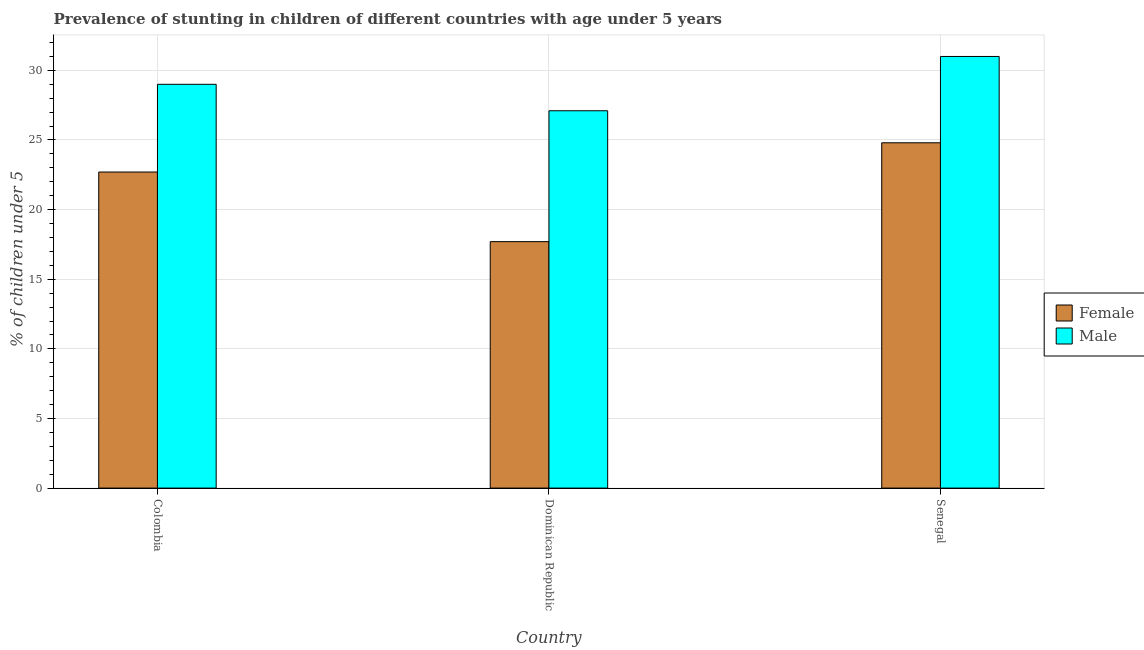How many groups of bars are there?
Keep it short and to the point. 3. Are the number of bars on each tick of the X-axis equal?
Keep it short and to the point. Yes. How many bars are there on the 1st tick from the left?
Offer a very short reply. 2. How many bars are there on the 3rd tick from the right?
Your answer should be compact. 2. What is the percentage of stunted female children in Colombia?
Offer a terse response. 22.7. Across all countries, what is the minimum percentage of stunted male children?
Give a very brief answer. 27.1. In which country was the percentage of stunted female children maximum?
Your answer should be very brief. Senegal. In which country was the percentage of stunted female children minimum?
Your response must be concise. Dominican Republic. What is the total percentage of stunted female children in the graph?
Your answer should be very brief. 65.2. What is the difference between the percentage of stunted female children in Colombia and that in Senegal?
Keep it short and to the point. -2.1. What is the difference between the percentage of stunted female children in Senegal and the percentage of stunted male children in Colombia?
Offer a very short reply. -4.2. What is the average percentage of stunted female children per country?
Provide a short and direct response. 21.73. What is the difference between the percentage of stunted female children and percentage of stunted male children in Colombia?
Offer a terse response. -6.3. What is the ratio of the percentage of stunted male children in Dominican Republic to that in Senegal?
Ensure brevity in your answer.  0.87. Is the difference between the percentage of stunted male children in Dominican Republic and Senegal greater than the difference between the percentage of stunted female children in Dominican Republic and Senegal?
Give a very brief answer. Yes. What is the difference between the highest and the second highest percentage of stunted female children?
Your answer should be very brief. 2.1. What is the difference between the highest and the lowest percentage of stunted male children?
Your answer should be very brief. 3.9. In how many countries, is the percentage of stunted female children greater than the average percentage of stunted female children taken over all countries?
Offer a terse response. 2. Is the sum of the percentage of stunted male children in Colombia and Dominican Republic greater than the maximum percentage of stunted female children across all countries?
Provide a succinct answer. Yes. What does the 1st bar from the left in Dominican Republic represents?
Your answer should be very brief. Female. What does the 2nd bar from the right in Colombia represents?
Your answer should be very brief. Female. How many bars are there?
Your response must be concise. 6. What is the difference between two consecutive major ticks on the Y-axis?
Your answer should be very brief. 5. Does the graph contain any zero values?
Your answer should be very brief. No. How many legend labels are there?
Provide a short and direct response. 2. How are the legend labels stacked?
Keep it short and to the point. Vertical. What is the title of the graph?
Provide a succinct answer. Prevalence of stunting in children of different countries with age under 5 years. What is the label or title of the X-axis?
Provide a succinct answer. Country. What is the label or title of the Y-axis?
Ensure brevity in your answer.   % of children under 5. What is the  % of children under 5 in Female in Colombia?
Offer a terse response. 22.7. What is the  % of children under 5 in Male in Colombia?
Offer a terse response. 29. What is the  % of children under 5 of Female in Dominican Republic?
Provide a succinct answer. 17.7. What is the  % of children under 5 in Male in Dominican Republic?
Offer a terse response. 27.1. What is the  % of children under 5 of Female in Senegal?
Keep it short and to the point. 24.8. What is the  % of children under 5 of Male in Senegal?
Offer a terse response. 31. Across all countries, what is the maximum  % of children under 5 of Female?
Offer a terse response. 24.8. Across all countries, what is the minimum  % of children under 5 in Female?
Provide a short and direct response. 17.7. Across all countries, what is the minimum  % of children under 5 in Male?
Ensure brevity in your answer.  27.1. What is the total  % of children under 5 of Female in the graph?
Offer a terse response. 65.2. What is the total  % of children under 5 of Male in the graph?
Offer a terse response. 87.1. What is the difference between the  % of children under 5 in Female in Colombia and that in Dominican Republic?
Ensure brevity in your answer.  5. What is the difference between the  % of children under 5 in Female in Colombia and that in Senegal?
Your answer should be compact. -2.1. What is the difference between the  % of children under 5 in Female in Dominican Republic and that in Senegal?
Offer a terse response. -7.1. What is the difference between the  % of children under 5 in Female in Colombia and the  % of children under 5 in Male in Senegal?
Keep it short and to the point. -8.3. What is the difference between the  % of children under 5 of Female in Dominican Republic and the  % of children under 5 of Male in Senegal?
Provide a short and direct response. -13.3. What is the average  % of children under 5 of Female per country?
Offer a very short reply. 21.73. What is the average  % of children under 5 of Male per country?
Make the answer very short. 29.03. What is the difference between the  % of children under 5 in Female and  % of children under 5 in Male in Colombia?
Provide a succinct answer. -6.3. What is the difference between the  % of children under 5 of Female and  % of children under 5 of Male in Dominican Republic?
Ensure brevity in your answer.  -9.4. What is the ratio of the  % of children under 5 of Female in Colombia to that in Dominican Republic?
Provide a succinct answer. 1.28. What is the ratio of the  % of children under 5 in Male in Colombia to that in Dominican Republic?
Offer a very short reply. 1.07. What is the ratio of the  % of children under 5 of Female in Colombia to that in Senegal?
Keep it short and to the point. 0.92. What is the ratio of the  % of children under 5 of Male in Colombia to that in Senegal?
Make the answer very short. 0.94. What is the ratio of the  % of children under 5 of Female in Dominican Republic to that in Senegal?
Offer a terse response. 0.71. What is the ratio of the  % of children under 5 in Male in Dominican Republic to that in Senegal?
Make the answer very short. 0.87. 